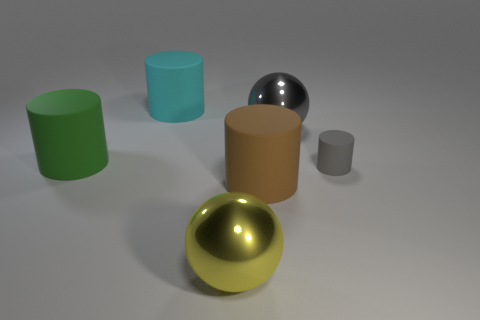Subtract 1 cylinders. How many cylinders are left? 3 Add 3 purple cubes. How many objects exist? 9 Subtract all spheres. How many objects are left? 4 Subtract all large blue rubber cylinders. Subtract all tiny gray matte cylinders. How many objects are left? 5 Add 6 brown rubber cylinders. How many brown rubber cylinders are left? 7 Add 4 yellow spheres. How many yellow spheres exist? 5 Subtract 1 gray cylinders. How many objects are left? 5 